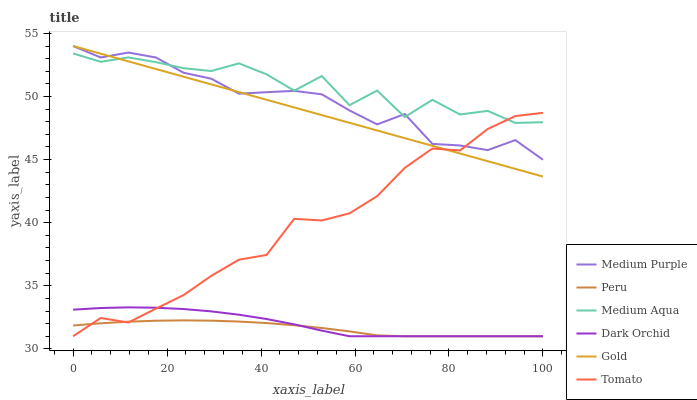Does Peru have the minimum area under the curve?
Answer yes or no. Yes. Does Medium Aqua have the maximum area under the curve?
Answer yes or no. Yes. Does Gold have the minimum area under the curve?
Answer yes or no. No. Does Gold have the maximum area under the curve?
Answer yes or no. No. Is Gold the smoothest?
Answer yes or no. Yes. Is Medium Aqua the roughest?
Answer yes or no. Yes. Is Dark Orchid the smoothest?
Answer yes or no. No. Is Dark Orchid the roughest?
Answer yes or no. No. Does Tomato have the lowest value?
Answer yes or no. Yes. Does Gold have the lowest value?
Answer yes or no. No. Does Medium Purple have the highest value?
Answer yes or no. Yes. Does Dark Orchid have the highest value?
Answer yes or no. No. Is Dark Orchid less than Gold?
Answer yes or no. Yes. Is Medium Aqua greater than Peru?
Answer yes or no. Yes. Does Tomato intersect Gold?
Answer yes or no. Yes. Is Tomato less than Gold?
Answer yes or no. No. Is Tomato greater than Gold?
Answer yes or no. No. Does Dark Orchid intersect Gold?
Answer yes or no. No. 